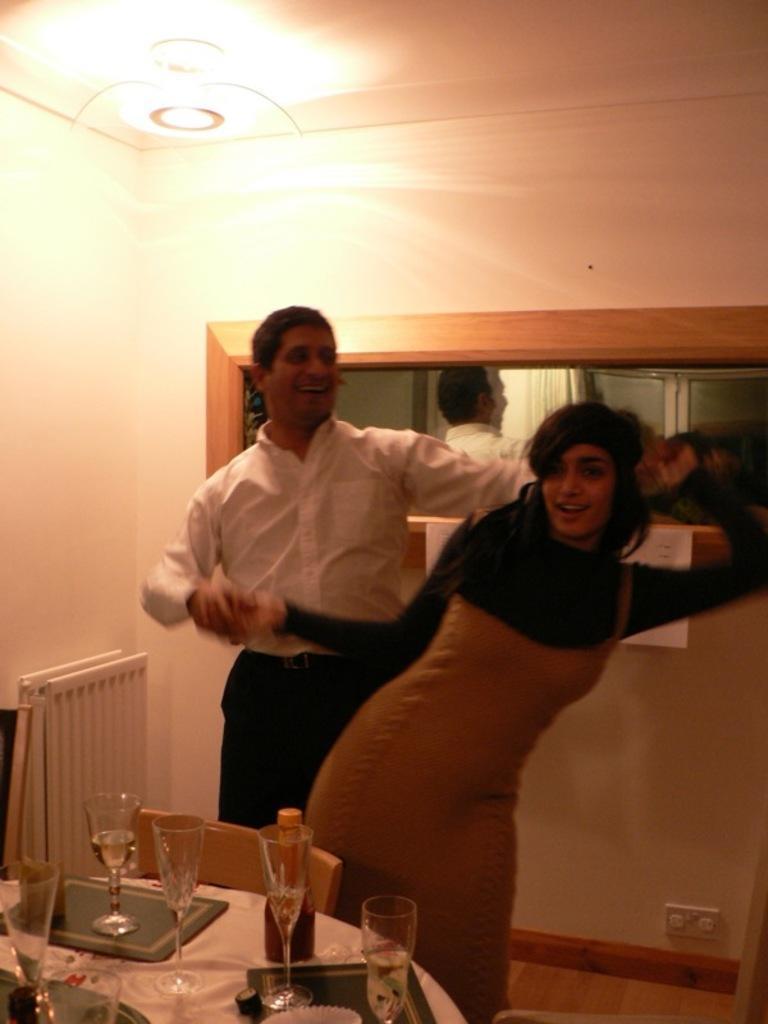Could you give a brief overview of what you see in this image? This picture is clicked inside the room. We see woman in black dress is standing in front of man and she is holding his hands. The man in white shirt behind her is catching her hands and he is smiling. I think both of them are dancing. Behind them, we see a mirror and a white wall. On the left bottom of the picture, we see a table on which glass, wine bottle, plate is please on it. 